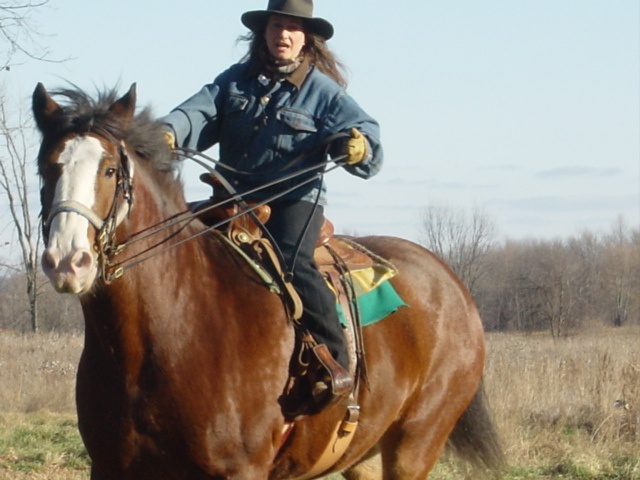Describe the objects in this image and their specific colors. I can see horse in lightblue, black, maroon, gray, and brown tones and people in lightblue, black, gray, and darkgray tones in this image. 